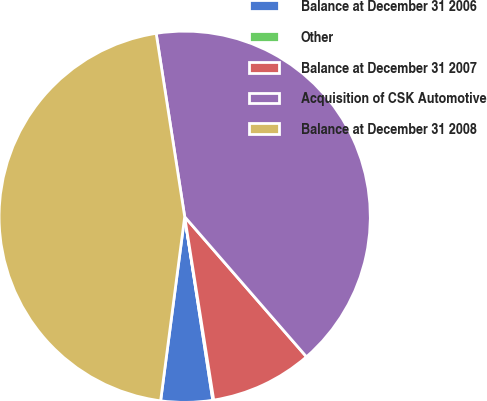<chart> <loc_0><loc_0><loc_500><loc_500><pie_chart><fcel>Balance at December 31 2006<fcel>Other<fcel>Balance at December 31 2007<fcel>Acquisition of CSK Automotive<fcel>Balance at December 31 2008<nl><fcel>4.49%<fcel>0.08%<fcel>8.89%<fcel>41.06%<fcel>45.47%<nl></chart> 